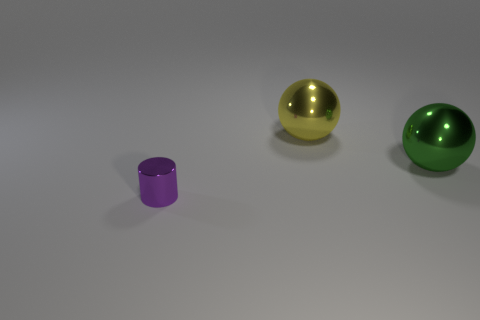Add 2 purple metal things. How many objects exist? 5 Subtract all yellow spheres. How many spheres are left? 1 Add 2 purple metal cylinders. How many purple metal cylinders are left? 3 Add 3 small blue rubber balls. How many small blue rubber balls exist? 3 Subtract 1 yellow balls. How many objects are left? 2 Subtract all cylinders. How many objects are left? 2 Subtract 1 balls. How many balls are left? 1 Subtract all purple balls. Subtract all blue cubes. How many balls are left? 2 Subtract all green matte spheres. Subtract all small cylinders. How many objects are left? 2 